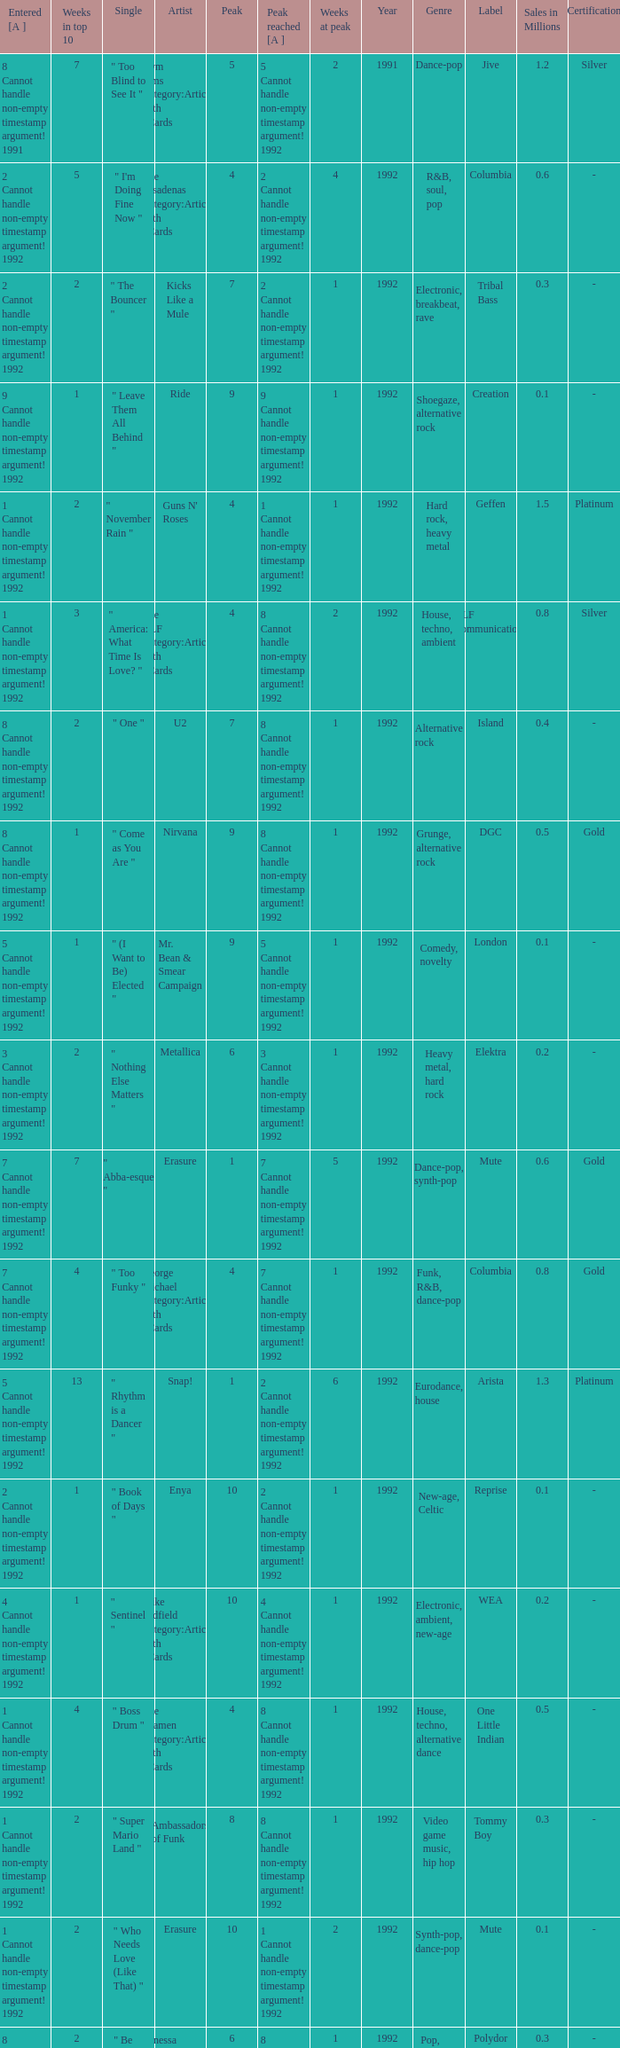What was the peak reached for a single with 4 weeks in the top 10 and entered in 7 cannot handle non-empty timestamp argument! 1992? 7 Cannot handle non-empty timestamp argument! 1992. 